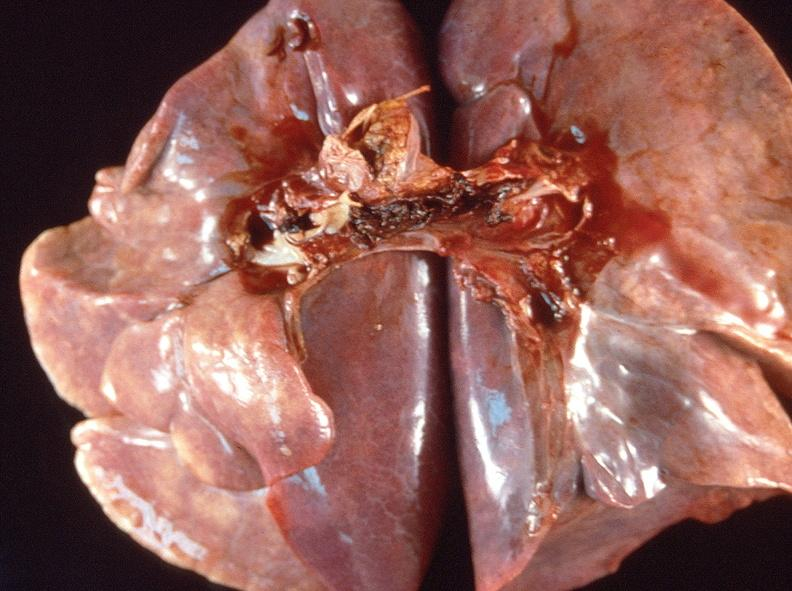where is this?
Answer the question using a single word or phrase. Lung 